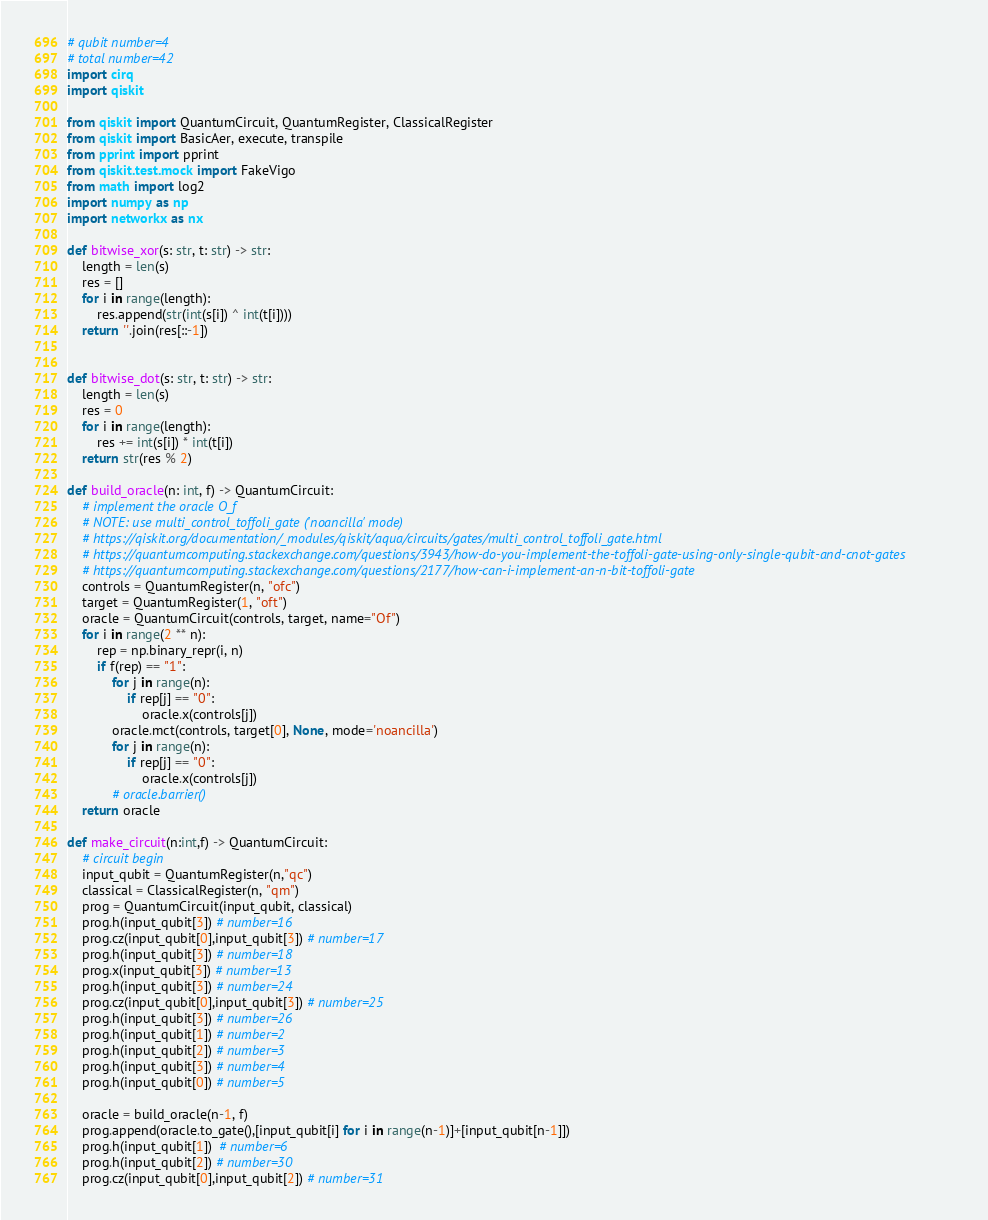Convert code to text. <code><loc_0><loc_0><loc_500><loc_500><_Python_># qubit number=4
# total number=42
import cirq
import qiskit

from qiskit import QuantumCircuit, QuantumRegister, ClassicalRegister
from qiskit import BasicAer, execute, transpile
from pprint import pprint
from qiskit.test.mock import FakeVigo
from math import log2
import numpy as np
import networkx as nx

def bitwise_xor(s: str, t: str) -> str:
    length = len(s)
    res = []
    for i in range(length):
        res.append(str(int(s[i]) ^ int(t[i])))
    return ''.join(res[::-1])


def bitwise_dot(s: str, t: str) -> str:
    length = len(s)
    res = 0
    for i in range(length):
        res += int(s[i]) * int(t[i])
    return str(res % 2)

def build_oracle(n: int, f) -> QuantumCircuit:
    # implement the oracle O_f
    # NOTE: use multi_control_toffoli_gate ('noancilla' mode)
    # https://qiskit.org/documentation/_modules/qiskit/aqua/circuits/gates/multi_control_toffoli_gate.html
    # https://quantumcomputing.stackexchange.com/questions/3943/how-do-you-implement-the-toffoli-gate-using-only-single-qubit-and-cnot-gates
    # https://quantumcomputing.stackexchange.com/questions/2177/how-can-i-implement-an-n-bit-toffoli-gate
    controls = QuantumRegister(n, "ofc")
    target = QuantumRegister(1, "oft")
    oracle = QuantumCircuit(controls, target, name="Of")
    for i in range(2 ** n):
        rep = np.binary_repr(i, n)
        if f(rep) == "1":
            for j in range(n):
                if rep[j] == "0":
                    oracle.x(controls[j])
            oracle.mct(controls, target[0], None, mode='noancilla')
            for j in range(n):
                if rep[j] == "0":
                    oracle.x(controls[j])
            # oracle.barrier()
    return oracle

def make_circuit(n:int,f) -> QuantumCircuit:
    # circuit begin
    input_qubit = QuantumRegister(n,"qc")
    classical = ClassicalRegister(n, "qm")
    prog = QuantumCircuit(input_qubit, classical)
    prog.h(input_qubit[3]) # number=16
    prog.cz(input_qubit[0],input_qubit[3]) # number=17
    prog.h(input_qubit[3]) # number=18
    prog.x(input_qubit[3]) # number=13
    prog.h(input_qubit[3]) # number=24
    prog.cz(input_qubit[0],input_qubit[3]) # number=25
    prog.h(input_qubit[3]) # number=26
    prog.h(input_qubit[1]) # number=2
    prog.h(input_qubit[2]) # number=3
    prog.h(input_qubit[3]) # number=4
    prog.h(input_qubit[0]) # number=5

    oracle = build_oracle(n-1, f)
    prog.append(oracle.to_gate(),[input_qubit[i] for i in range(n-1)]+[input_qubit[n-1]])
    prog.h(input_qubit[1])  # number=6
    prog.h(input_qubit[2]) # number=30
    prog.cz(input_qubit[0],input_qubit[2]) # number=31</code> 